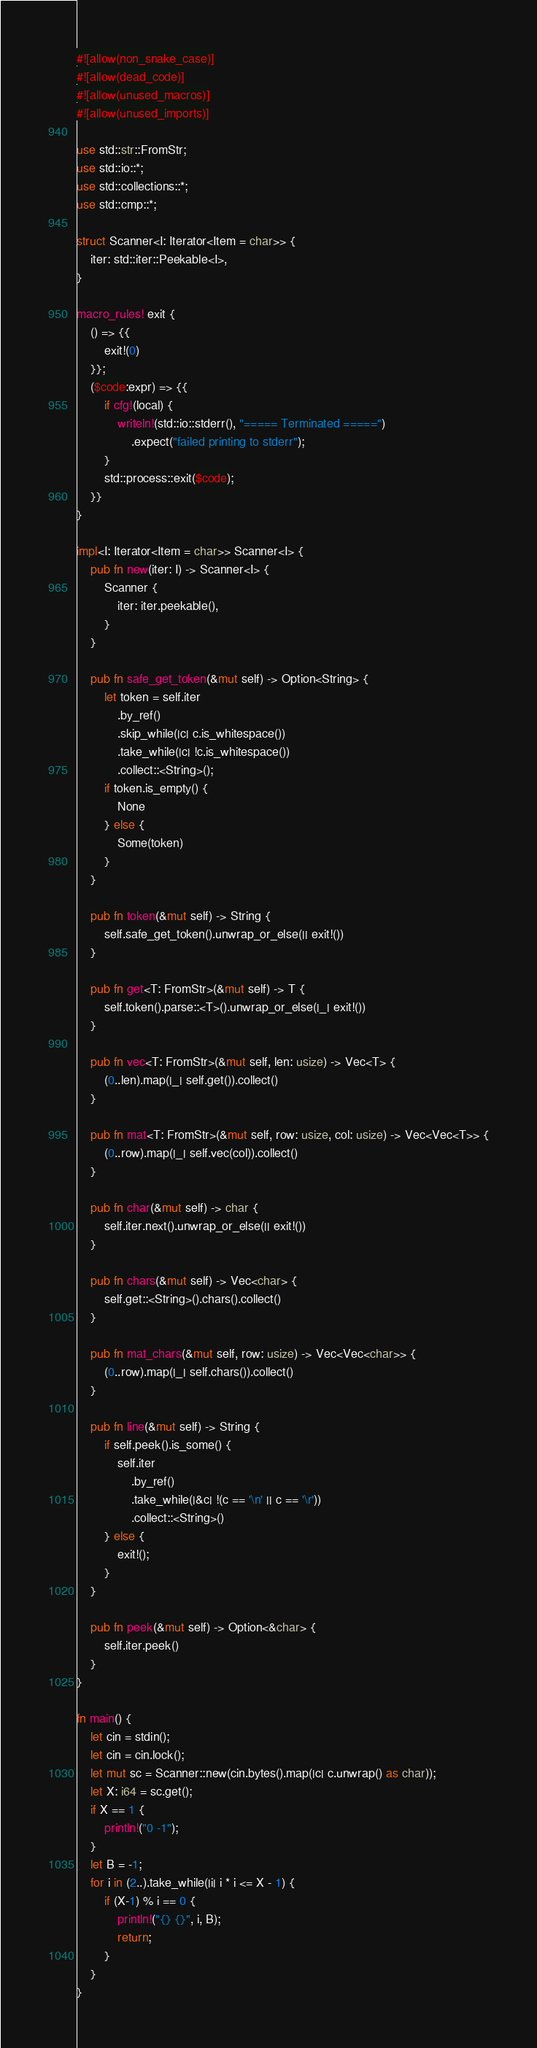<code> <loc_0><loc_0><loc_500><loc_500><_Rust_>#![allow(non_snake_case)]
#![allow(dead_code)]
#![allow(unused_macros)]
#![allow(unused_imports)]

use std::str::FromStr;
use std::io::*;
use std::collections::*;
use std::cmp::*;

struct Scanner<I: Iterator<Item = char>> {
    iter: std::iter::Peekable<I>,
}

macro_rules! exit {
    () => {{
        exit!(0)
    }};
    ($code:expr) => {{
        if cfg!(local) {
            writeln!(std::io::stderr(), "===== Terminated =====")
                .expect("failed printing to stderr");
        }
        std::process::exit($code);
    }}
}

impl<I: Iterator<Item = char>> Scanner<I> {
    pub fn new(iter: I) -> Scanner<I> {
        Scanner {
            iter: iter.peekable(),
        }
    }

    pub fn safe_get_token(&mut self) -> Option<String> {
        let token = self.iter
            .by_ref()
            .skip_while(|c| c.is_whitespace())
            .take_while(|c| !c.is_whitespace())
            .collect::<String>();
        if token.is_empty() {
            None
        } else {
            Some(token)
        }
    }

    pub fn token(&mut self) -> String {
        self.safe_get_token().unwrap_or_else(|| exit!())
    }

    pub fn get<T: FromStr>(&mut self) -> T {
        self.token().parse::<T>().unwrap_or_else(|_| exit!())
    }

    pub fn vec<T: FromStr>(&mut self, len: usize) -> Vec<T> {
        (0..len).map(|_| self.get()).collect()
    }

    pub fn mat<T: FromStr>(&mut self, row: usize, col: usize) -> Vec<Vec<T>> {
        (0..row).map(|_| self.vec(col)).collect()
    }

    pub fn char(&mut self) -> char {
        self.iter.next().unwrap_or_else(|| exit!())
    }

    pub fn chars(&mut self) -> Vec<char> {
        self.get::<String>().chars().collect()
    }

    pub fn mat_chars(&mut self, row: usize) -> Vec<Vec<char>> {
        (0..row).map(|_| self.chars()).collect()
    }

    pub fn line(&mut self) -> String {
        if self.peek().is_some() {
            self.iter
                .by_ref()
                .take_while(|&c| !(c == '\n' || c == '\r'))
                .collect::<String>()
        } else {
            exit!();
        }
    }

    pub fn peek(&mut self) -> Option<&char> {
        self.iter.peek()
    }
}

fn main() {
    let cin = stdin();
    let cin = cin.lock();
    let mut sc = Scanner::new(cin.bytes().map(|c| c.unwrap() as char));
    let X: i64 = sc.get();
    if X == 1 {
        println!("0 -1");
    }
    let B = -1;
    for i in (2..).take_while(|i| i * i <= X - 1) {
        if (X-1) % i == 0 {
            println!("{} {}", i, B);
            return;
        }
    }
}
</code> 